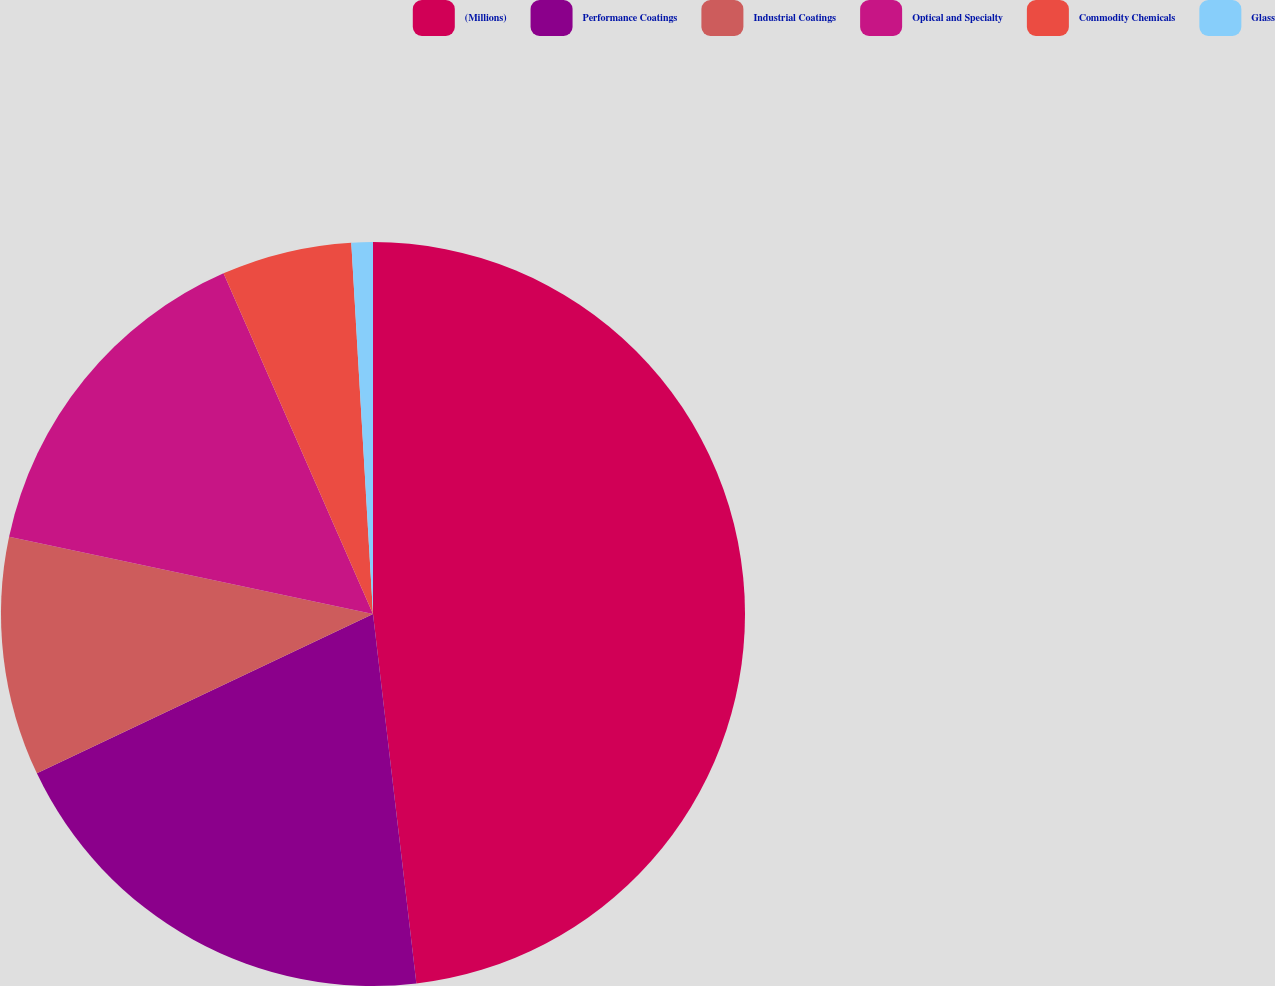<chart> <loc_0><loc_0><loc_500><loc_500><pie_chart><fcel>(Millions)<fcel>Performance Coatings<fcel>Industrial Coatings<fcel>Optical and Specialty<fcel>Commodity Chemicals<fcel>Glass<nl><fcel>48.13%<fcel>19.81%<fcel>10.37%<fcel>15.09%<fcel>5.65%<fcel>0.93%<nl></chart> 